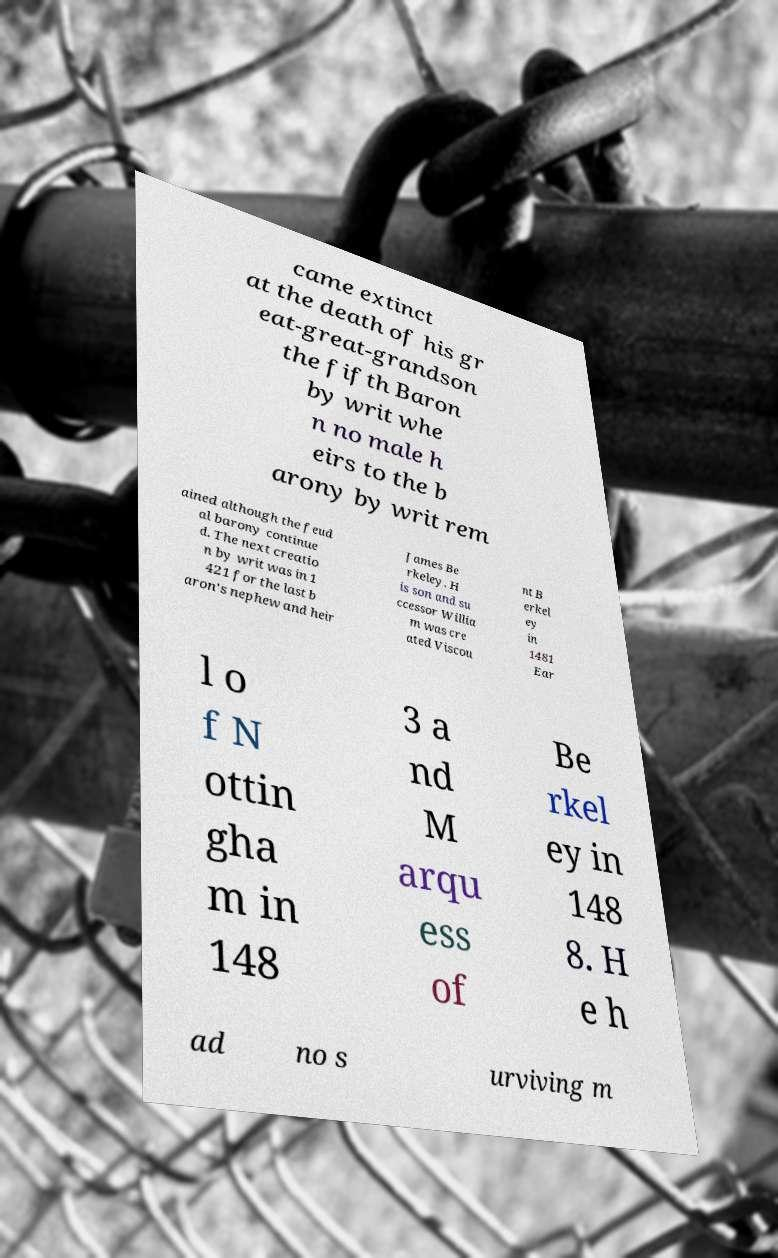Could you assist in decoding the text presented in this image and type it out clearly? came extinct at the death of his gr eat-great-grandson the fifth Baron by writ whe n no male h eirs to the b arony by writ rem ained although the feud al barony continue d. The next creatio n by writ was in 1 421 for the last b aron's nephew and heir James Be rkeley. H is son and su ccessor Willia m was cre ated Viscou nt B erkel ey in 1481 Ear l o f N ottin gha m in 148 3 a nd M arqu ess of Be rkel ey in 148 8. H e h ad no s urviving m 